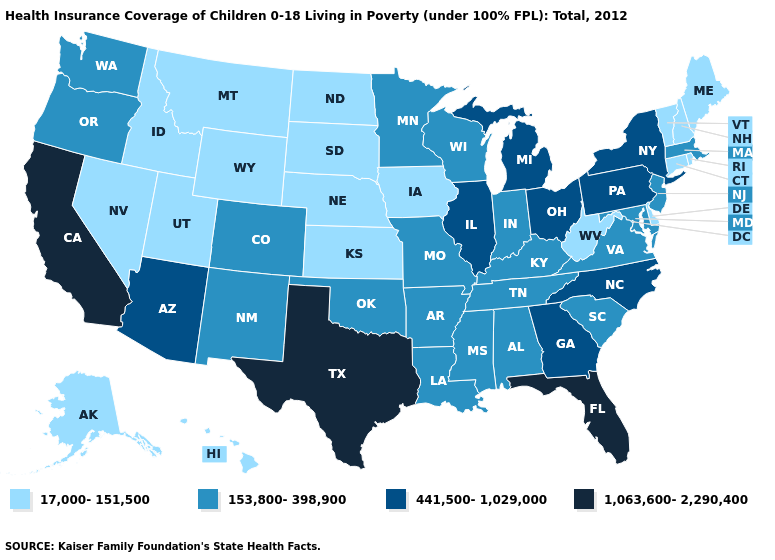What is the lowest value in states that border Utah?
Write a very short answer. 17,000-151,500. What is the value of Illinois?
Write a very short answer. 441,500-1,029,000. Does Pennsylvania have the lowest value in the Northeast?
Short answer required. No. Which states have the lowest value in the West?
Quick response, please. Alaska, Hawaii, Idaho, Montana, Nevada, Utah, Wyoming. Among the states that border Mississippi , which have the highest value?
Write a very short answer. Alabama, Arkansas, Louisiana, Tennessee. Does Georgia have the same value as South Carolina?
Keep it brief. No. What is the highest value in states that border Maryland?
Quick response, please. 441,500-1,029,000. Does Alabama have the highest value in the USA?
Be succinct. No. What is the highest value in states that border Maine?
Write a very short answer. 17,000-151,500. Which states have the lowest value in the MidWest?
Be succinct. Iowa, Kansas, Nebraska, North Dakota, South Dakota. Name the states that have a value in the range 1,063,600-2,290,400?
Concise answer only. California, Florida, Texas. Does Massachusetts have a higher value than Connecticut?
Answer briefly. Yes. Does the map have missing data?
Write a very short answer. No. Does Vermont have a lower value than Nevada?
Give a very brief answer. No. What is the value of New Jersey?
Short answer required. 153,800-398,900. 